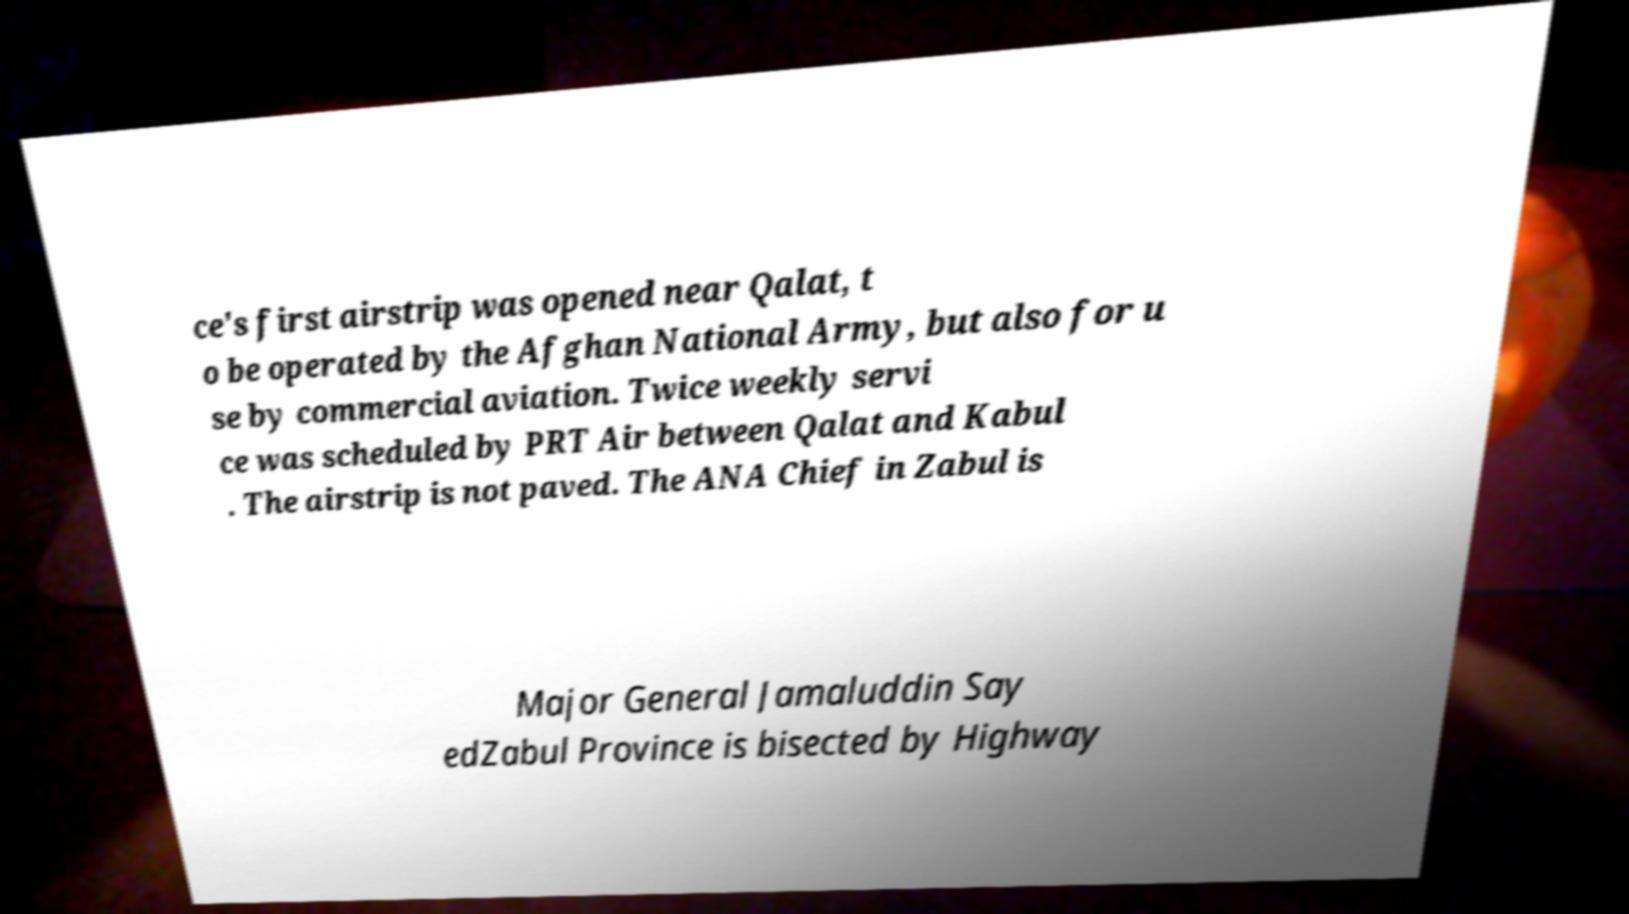For documentation purposes, I need the text within this image transcribed. Could you provide that? ce's first airstrip was opened near Qalat, t o be operated by the Afghan National Army, but also for u se by commercial aviation. Twice weekly servi ce was scheduled by PRT Air between Qalat and Kabul . The airstrip is not paved. The ANA Chief in Zabul is Major General Jamaluddin Say edZabul Province is bisected by Highway 